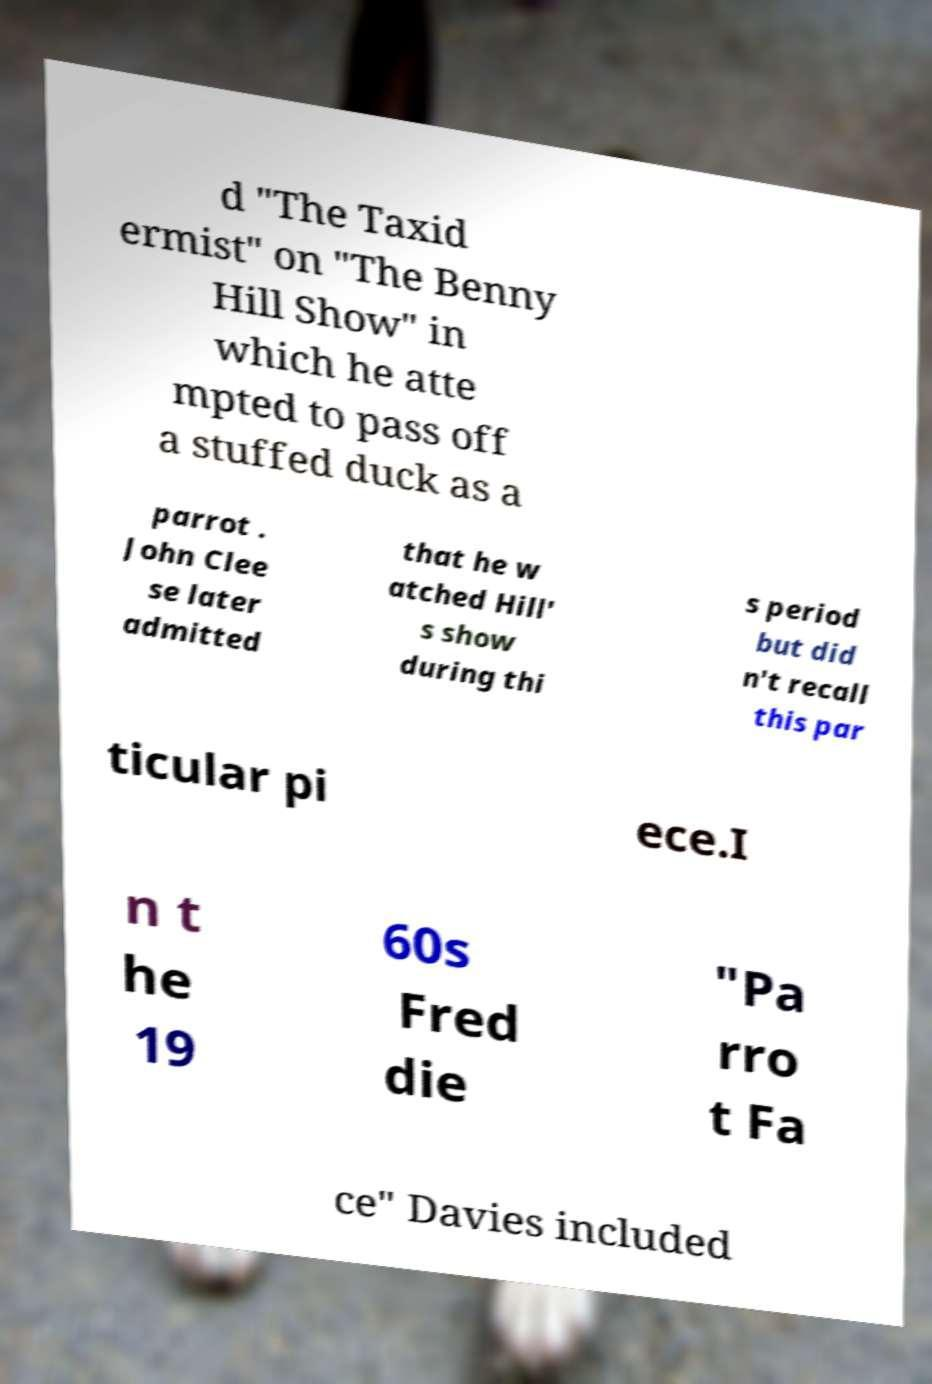Could you assist in decoding the text presented in this image and type it out clearly? d "The Taxid ermist" on "The Benny Hill Show" in which he atte mpted to pass off a stuffed duck as a parrot . John Clee se later admitted that he w atched Hill' s show during thi s period but did n't recall this par ticular pi ece.I n t he 19 60s Fred die "Pa rro t Fa ce" Davies included 